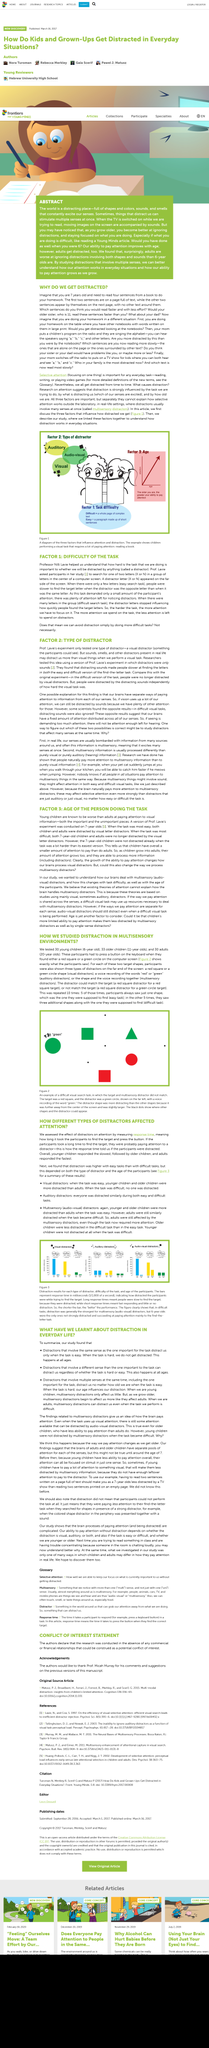Mention a couple of crucial points in this snapshot. The effect of distractors on attention was assessed by measuring response time. This article explores the impact of distractors on attention and how they can significantly impact cognitive processes. The younger children responded the slowest, as indicated by the results of the study. 